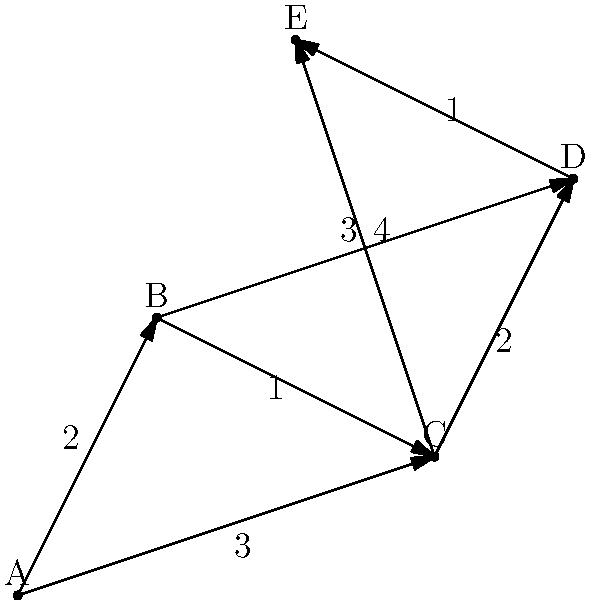You're planning a kayaking trip around five islands in the Florida Keys, labeled A through E. The graph shows the possible routes between islands, with arrows indicating the direction of travel and numbers representing the distance in miles. Starting from island A, what is the shortest route that visits all islands exactly once and returns to island A? To find the shortest route, we'll use the Traveling Salesman Problem (TSP) approach:

1. List all possible routes starting and ending at A:
   A-B-C-D-E-A
   A-B-C-E-D-A
   A-B-D-C-E-A
   A-B-D-E-C-A
   A-B-E-C-D-A
   A-B-E-D-C-A
   A-C-B-D-E-A
   A-C-B-E-D-A
   A-C-D-B-E-A
   A-C-D-E-B-A
   A-C-E-B-D-A
   A-C-E-D-B-A

2. Calculate the total distance for each route:
   A-B-C-D-E-A: 2 + 1 + 2 + 1 + 3 = 9 miles
   A-B-C-E-D-A: 2 + 1 + 3 + 1 + 4 = 11 miles
   A-B-D-C-E-A: 2 + 4 + 2 + 3 + 3 = 14 miles
   A-B-D-E-C-A: 2 + 4 + 1 + 3 + 3 = 13 miles
   A-B-E-C-D-A: 2 + 4 + 3 + 2 + 3 = 14 miles
   A-B-E-D-C-A: 2 + 4 + 1 + 2 + 3 = 12 miles
   A-C-B-D-E-A: 3 + 1 + 4 + 1 + 3 = 12 miles
   A-C-B-E-D-A: 3 + 1 + 4 + 1 + 4 = 13 miles
   A-C-D-B-E-A: 3 + 2 + 4 + 4 + 3 = 16 miles
   A-C-D-E-B-A: 3 + 2 + 1 + 4 + 2 = 12 miles
   A-C-E-B-D-A: 3 + 3 + 4 + 4 + 3 = 17 miles
   A-C-E-D-B-A: 3 + 3 + 1 + 4 + 2 = 13 miles

3. Identify the shortest route:
   The shortest route is A-B-C-D-E-A with a total distance of 9 miles.
Answer: A-B-C-D-E-A (9 miles) 